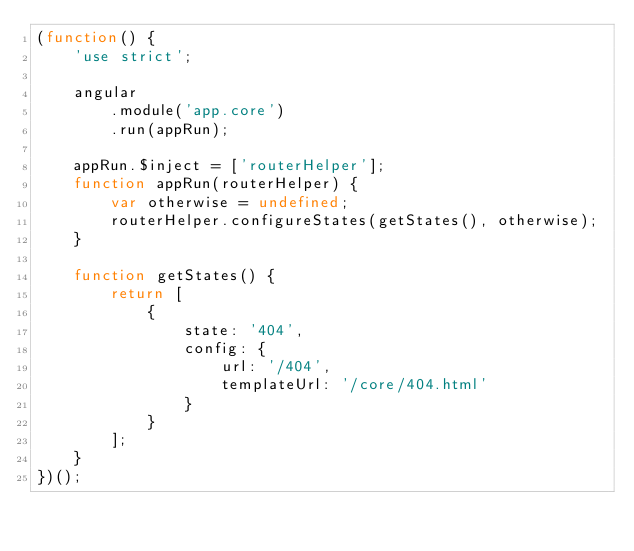Convert code to text. <code><loc_0><loc_0><loc_500><loc_500><_JavaScript_>(function() {
    'use strict';

    angular
        .module('app.core')
        .run(appRun);

    appRun.$inject = ['routerHelper'];
    function appRun(routerHelper) {
        var otherwise = undefined;
        routerHelper.configureStates(getStates(), otherwise);
    }

    function getStates() {
        return [
            {
                state: '404',
                config: {
                    url: '/404',
                    templateUrl: '/core/404.html'
                }
            }
        ];
    }
})();
</code> 